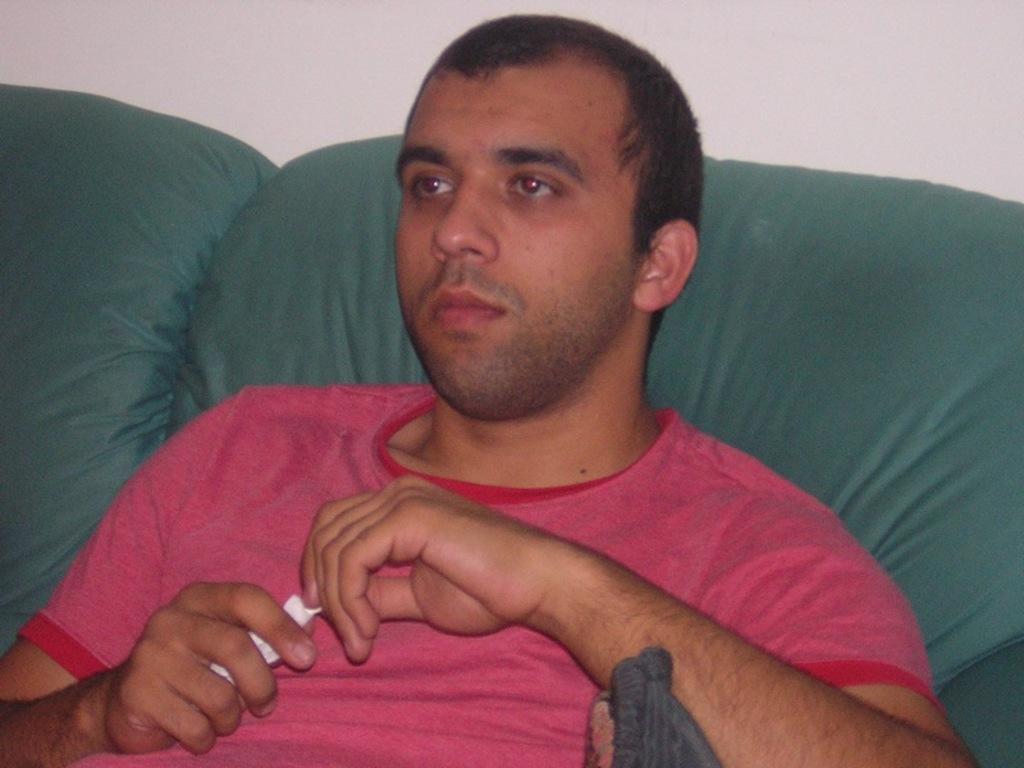In one or two sentences, can you explain what this image depicts? In the center of the image we can see one person sitting on the couch and he is holding some object. In front of him, we can see one ash color object. In the background there is a wall and a couch, which is in green color. 